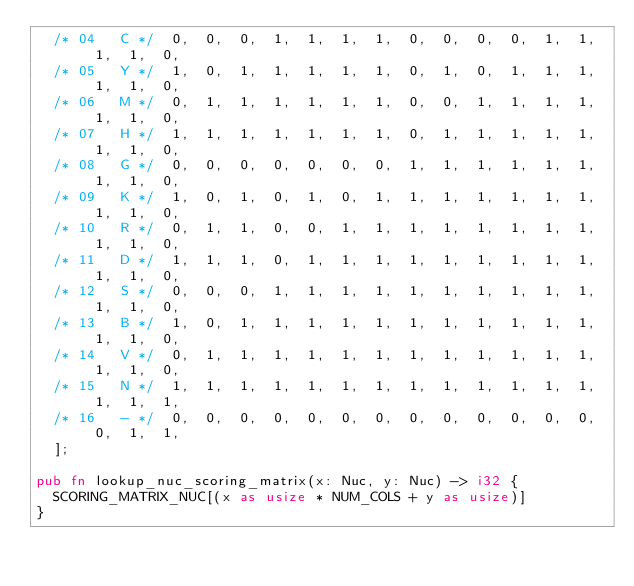Convert code to text. <code><loc_0><loc_0><loc_500><loc_500><_Rust_>  /* 04   C */  0,  0,  0,  1,  1,  1,  1,  0,  0,  0,  0,  1,  1,  1,  1,  0,
  /* 05   Y */  1,  0,  1,  1,  1,  1,  1,  0,  1,  0,  1,  1,  1,  1,  1,  0,
  /* 06   M */  0,  1,  1,  1,  1,  1,  1,  0,  0,  1,  1,  1,  1,  1,  1,  0,
  /* 07   H */  1,  1,  1,  1,  1,  1,  1,  0,  1,  1,  1,  1,  1,  1,  1,  0,
  /* 08   G */  0,  0,  0,  0,  0,  0,  0,  1,  1,  1,  1,  1,  1,  1,  1,  0,
  /* 09   K */  1,  0,  1,  0,  1,  0,  1,  1,  1,  1,  1,  1,  1,  1,  1,  0,
  /* 10   R */  0,  1,  1,  0,  0,  1,  1,  1,  1,  1,  1,  1,  1,  1,  1,  0,
  /* 11   D */  1,  1,  1,  0,  1,  1,  1,  1,  1,  1,  1,  1,  1,  1,  1,  0,
  /* 12   S */  0,  0,  0,  1,  1,  1,  1,  1,  1,  1,  1,  1,  1,  1,  1,  0,
  /* 13   B */  1,  0,  1,  1,  1,  1,  1,  1,  1,  1,  1,  1,  1,  1,  1,  0,
  /* 14   V */  0,  1,  1,  1,  1,  1,  1,  1,  1,  1,  1,  1,  1,  1,  1,  0,
  /* 15   N */  1,  1,  1,  1,  1,  1,  1,  1,  1,  1,  1,  1,  1,  1,  1,  1,
  /* 16   - */  0,  0,  0,  0,  0,  0,  0,  0,  0,  0,  0,  0,  0,  0,  1,  1,
  ];

pub fn lookup_nuc_scoring_matrix(x: Nuc, y: Nuc) -> i32 {
  SCORING_MATRIX_NUC[(x as usize * NUM_COLS + y as usize)]
}
</code> 